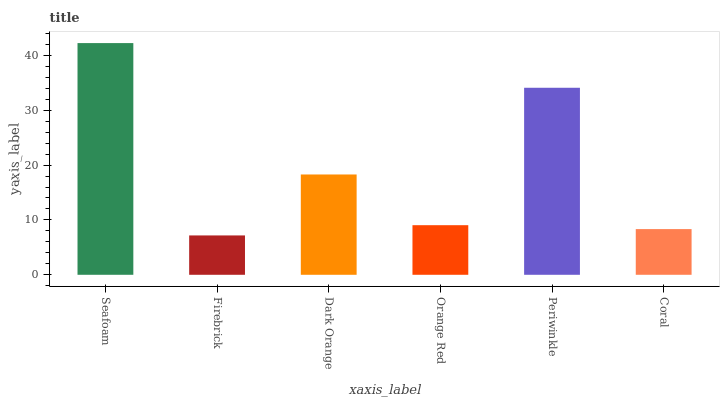Is Dark Orange the minimum?
Answer yes or no. No. Is Dark Orange the maximum?
Answer yes or no. No. Is Dark Orange greater than Firebrick?
Answer yes or no. Yes. Is Firebrick less than Dark Orange?
Answer yes or no. Yes. Is Firebrick greater than Dark Orange?
Answer yes or no. No. Is Dark Orange less than Firebrick?
Answer yes or no. No. Is Dark Orange the high median?
Answer yes or no. Yes. Is Orange Red the low median?
Answer yes or no. Yes. Is Orange Red the high median?
Answer yes or no. No. Is Periwinkle the low median?
Answer yes or no. No. 